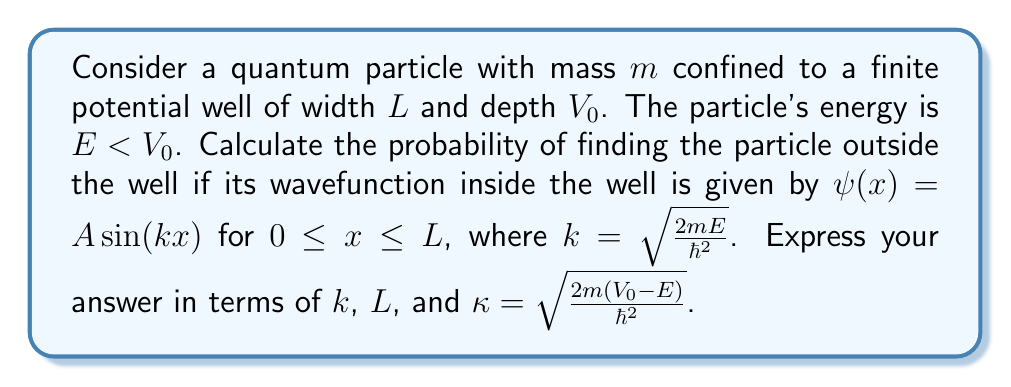Could you help me with this problem? To solve this problem, we'll follow these steps:

1) First, we need to understand that the wavefunction outside the well decays exponentially. It has the form:
   $\psi(x) = Be^{-\kappa x}$ for $x > L$, where $\kappa = \sqrt{\frac{2m(V_0-E)}{\hbar^2}}$

2) The wavefunction and its derivative must be continuous at $x = L$. This gives us two equations:

   $A \sin(kL) = Be^{-\kappa L}$
   $Ak \cos(kL) = -B\kappa e^{-\kappa L}$

3) Dividing these equations:

   $\tan(kL) = -\frac{k}{\kappa}$

4) The probability of finding the particle outside the well is:

   $P = \int_L^{\infty} |\psi(x)|^2 dx = B^2 \int_L^{\infty} e^{-2\kappa x} dx = \frac{B^2}{2\kappa}e^{-2\kappa L}$

5) We need to find $B$ in terms of $A$. From step 2:

   $B = A \sin(kL) e^{\kappa L}$

6) Substituting this into the probability equation:

   $P = \frac{A^2 \sin^2(kL)}{2\kappa}$

7) To find $A$, we use the normalization condition:

   $1 = \int_0^L A^2 \sin^2(kx) dx + \frac{A^2 \sin^2(kL)}{2\kappa}$

8) Solving this integral:

   $1 = A^2 (\frac{L}{2} - \frac{\sin(2kL)}{4k} + \frac{\sin^2(kL)}{2\kappa})$

9) Therefore:

   $A^2 = \frac{2}{2L - \frac{\sin(2kL)}{k} + \frac{2\sin^2(kL)}{\kappa}}$

10) Substituting this back into the probability equation:

    $P = \frac{\sin^2(kL)}{\kappa(2L - \frac{\sin(2kL)}{k} + \frac{2\sin^2(kL)}{\kappa})}$

This is our final expression for the probability of finding the particle outside the well.
Answer: $P = \frac{\sin^2(kL)}{\kappa(2L - \frac{\sin(2kL)}{k} + \frac{2\sin^2(kL)}{\kappa})}$ 